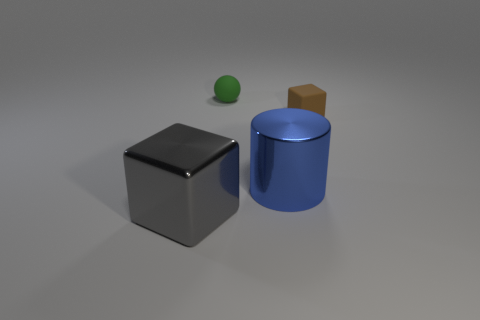What material do the objects in the image seem to be made of? The objects in the image appear to be made of different materials. The cube looks like it might be metallic, given its shiny surface and sharp reflections, while the cylinder has a matte finish that suggests it could be made of plastic or painted metal. The small sphere seems to have a smooth texture, which might indicate it's made of rubber or a similar material. 